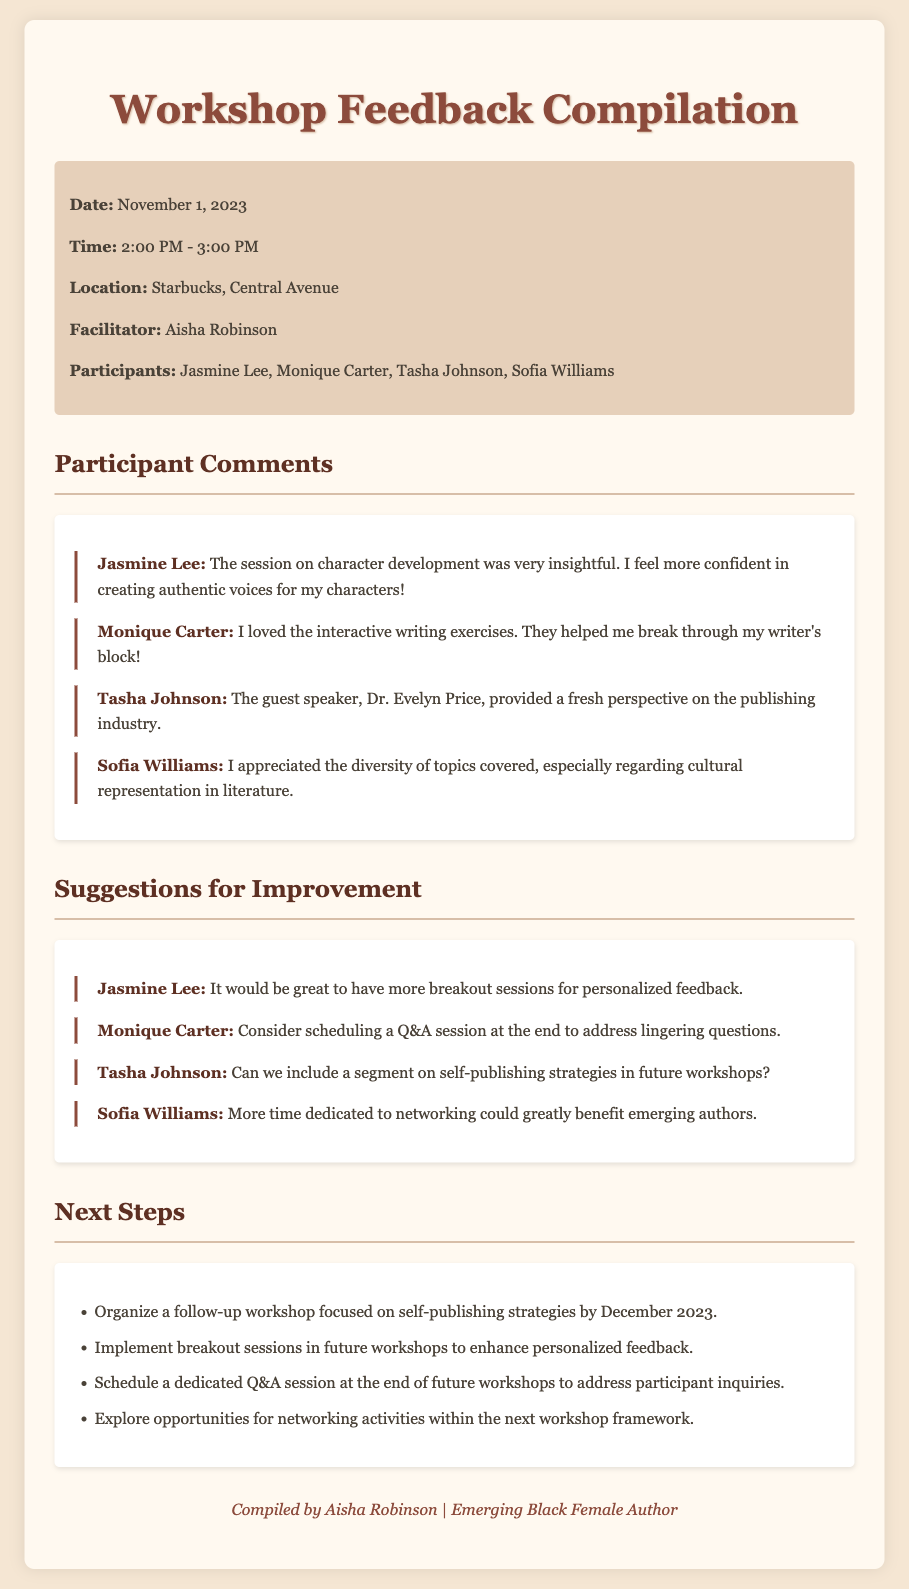what is the date of the workshop? The date is specified in the document under the info section as November 1, 2023.
Answer: November 1, 2023 who was the facilitator of the workshop? The facilitator's name is mentioned in the info section of the document as Aisha Robinson.
Answer: Aisha Robinson which participant mentioned character development? Jasmine Lee is the participant who commented on character development in the feedback section.
Answer: Jasmine Lee what suggestion did Tasha Johnson provide? Tasha Johnson's suggestion, found under Suggestions for Improvement, is to include a segment on self-publishing strategies.
Answer: self-publishing strategies how many participants are listed in the document? The document lists a total of four participants in the info section.
Answer: four what is one of the next steps mentioned? The next steps section outlines several actions, one of which is to organize a follow-up workshop focused on self-publishing strategies.
Answer: follow-up workshop focused on self-publishing strategies what was appreciated about the diversity of topics? Sofia Williams appreciated the diversity of topics, particularly regarding cultural representation in literature.
Answer: cultural representation in literature how long did the workshop last? The time frame indicates that the workshop lasted from 2:00 PM to 3:00 PM, making it one hour long.
Answer: one hour 